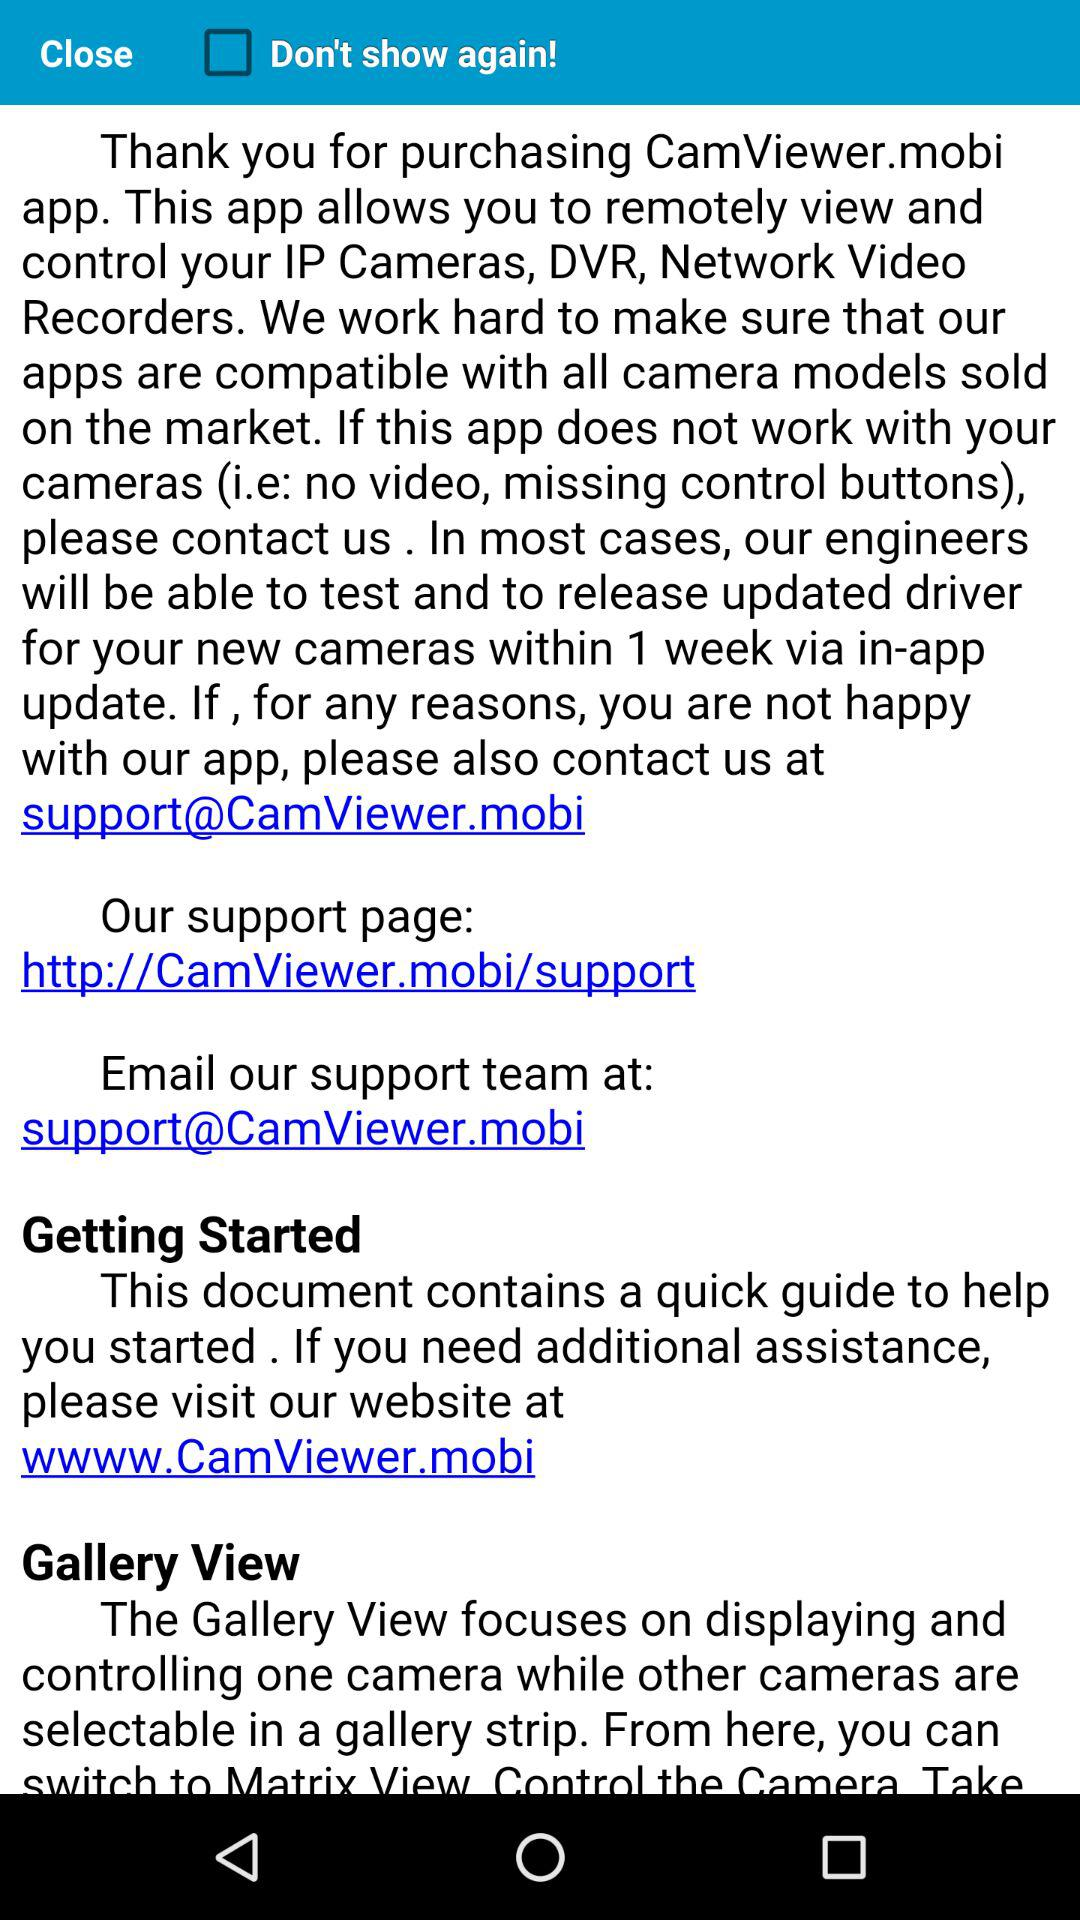What is the email address? The email address is support@CamViewer.mobi. 